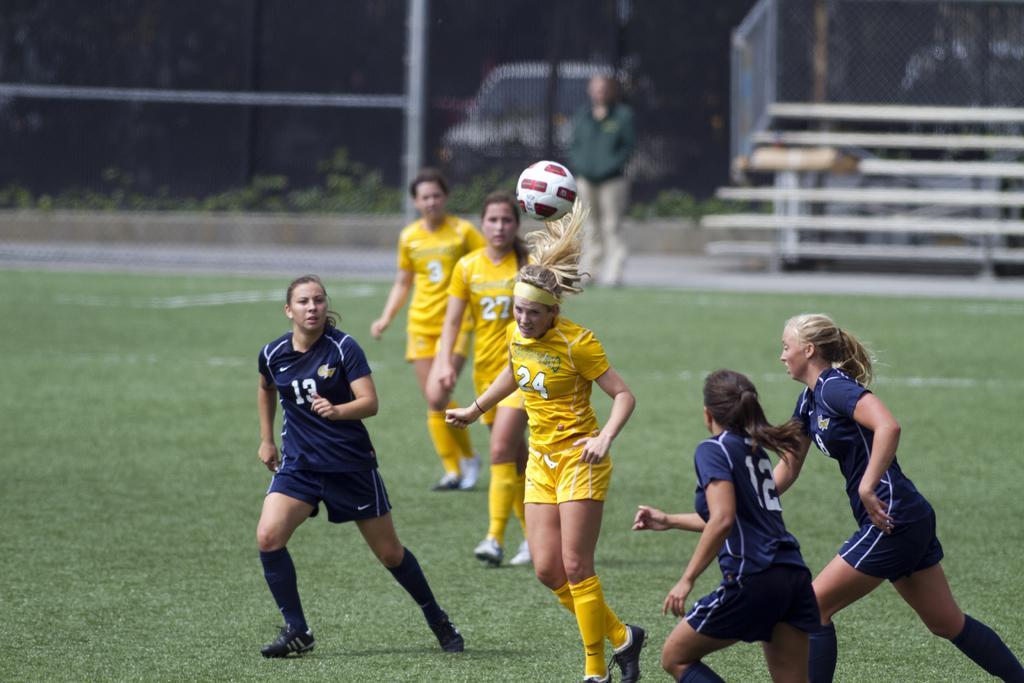Please provide a concise description of this image. In the center we can see six persons were standing. Three of them wearing yellow t shirt and rest three of them were wearing blue t shirt. In the background there is a vehicle,plant,grass,steps and one person standing. 